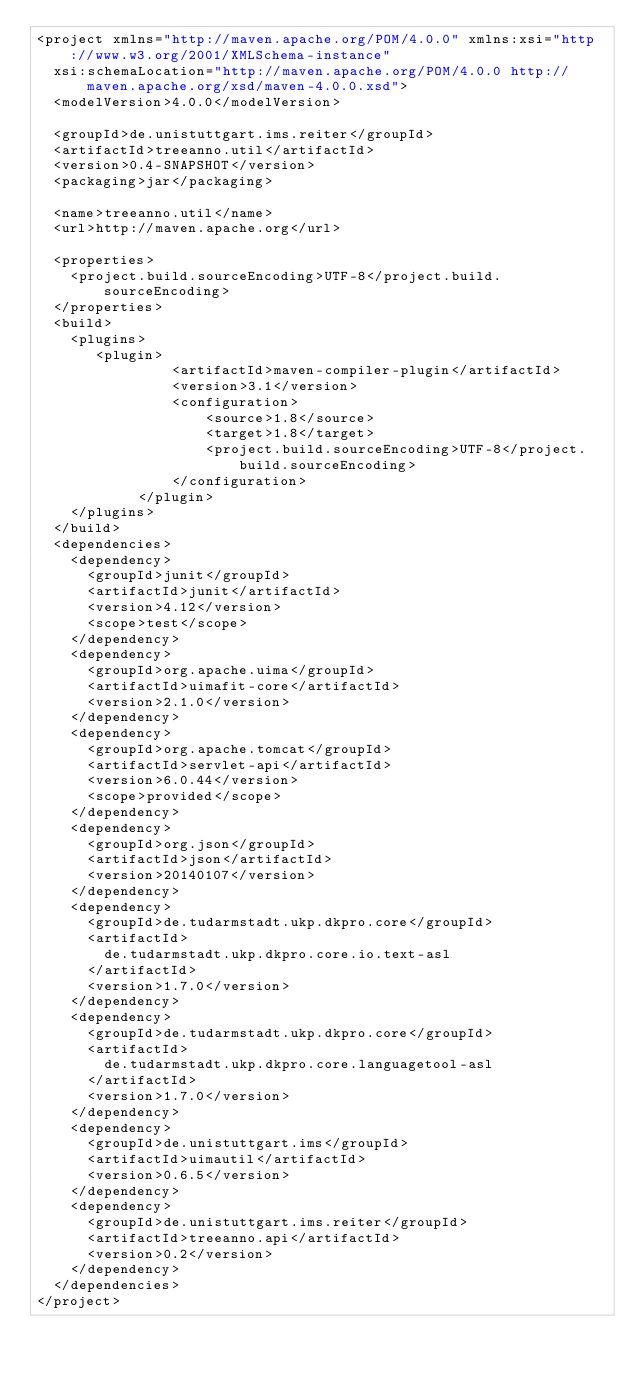<code> <loc_0><loc_0><loc_500><loc_500><_XML_><project xmlns="http://maven.apache.org/POM/4.0.0" xmlns:xsi="http://www.w3.org/2001/XMLSchema-instance"
  xsi:schemaLocation="http://maven.apache.org/POM/4.0.0 http://maven.apache.org/xsd/maven-4.0.0.xsd">
  <modelVersion>4.0.0</modelVersion>

  <groupId>de.unistuttgart.ims.reiter</groupId>
  <artifactId>treeanno.util</artifactId>
  <version>0.4-SNAPSHOT</version>
  <packaging>jar</packaging>

  <name>treeanno.util</name>
  <url>http://maven.apache.org</url>

  <properties>
    <project.build.sourceEncoding>UTF-8</project.build.sourceEncoding>
  </properties>
  <build>
  	<plugins>
  		 <plugin>
                <artifactId>maven-compiler-plugin</artifactId>
                <version>3.1</version>
                <configuration>
                    <source>1.8</source>
                    <target>1.8</target>
                    <project.build.sourceEncoding>UTF-8</project.build.sourceEncoding>
                </configuration>
            </plugin>
  	</plugins>
  </build>
  <dependencies>
  	<dependency>
  		<groupId>junit</groupId>
  		<artifactId>junit</artifactId>
  		<version>4.12</version>
  		<scope>test</scope>
  	</dependency>
  	<dependency>
  		<groupId>org.apache.uima</groupId>
  		<artifactId>uimafit-core</artifactId>
  		<version>2.1.0</version>
  	</dependency>
  	<dependency>
    	<groupId>org.apache.tomcat</groupId>
    	<artifactId>servlet-api</artifactId>
    	<version>6.0.44</version>
    	<scope>provided</scope>
    </dependency>
    <dependency>
  		<groupId>org.json</groupId>
  		<artifactId>json</artifactId>
  		<version>20140107</version>
  	</dependency>
    <dependency>
    	<groupId>de.tudarmstadt.ukp.dkpro.core</groupId>
    	<artifactId>
    		de.tudarmstadt.ukp.dkpro.core.io.text-asl
    	</artifactId>
    	<version>1.7.0</version>
    </dependency>
    <dependency>
    	<groupId>de.tudarmstadt.ukp.dkpro.core</groupId>
    	<artifactId>
    		de.tudarmstadt.ukp.dkpro.core.languagetool-asl
    	</artifactId>
    	<version>1.7.0</version>
    </dependency>
    <dependency>
    	<groupId>de.unistuttgart.ims</groupId>
    	<artifactId>uimautil</artifactId>
    	<version>0.6.5</version>
    </dependency>
    <dependency>
    	<groupId>de.unistuttgart.ims.reiter</groupId>
    	<artifactId>treeanno.api</artifactId>
    	<version>0.2</version>
    </dependency>
  </dependencies>
</project>
</code> 